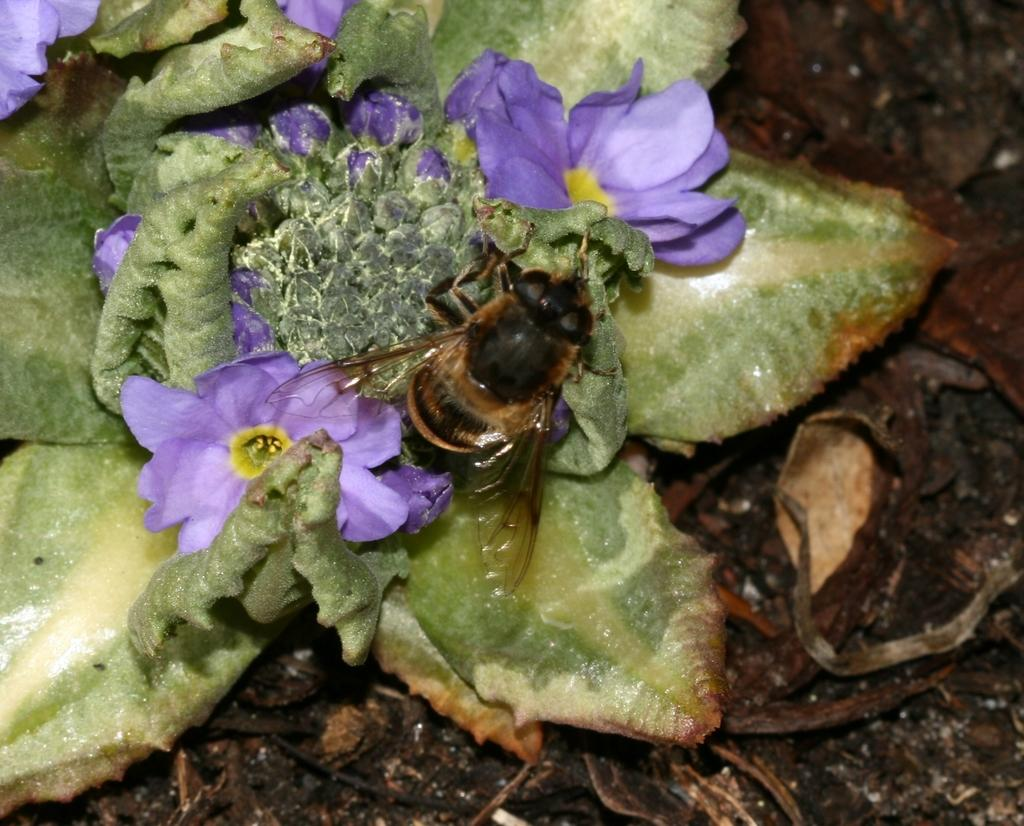Where was the image taken? The image is taken outdoors. What can be seen at the bottom of the image? There is soil at the bottom of the image. What type of plant is on the left side of the image? There is a plant with flowers on the left side of the image. What is present on the plant? There is a honey bee on the plant. What type of shop is represented on the page in the image? There is no shop or page present in the image; it features an outdoor scene with a plant and a honey bee. 